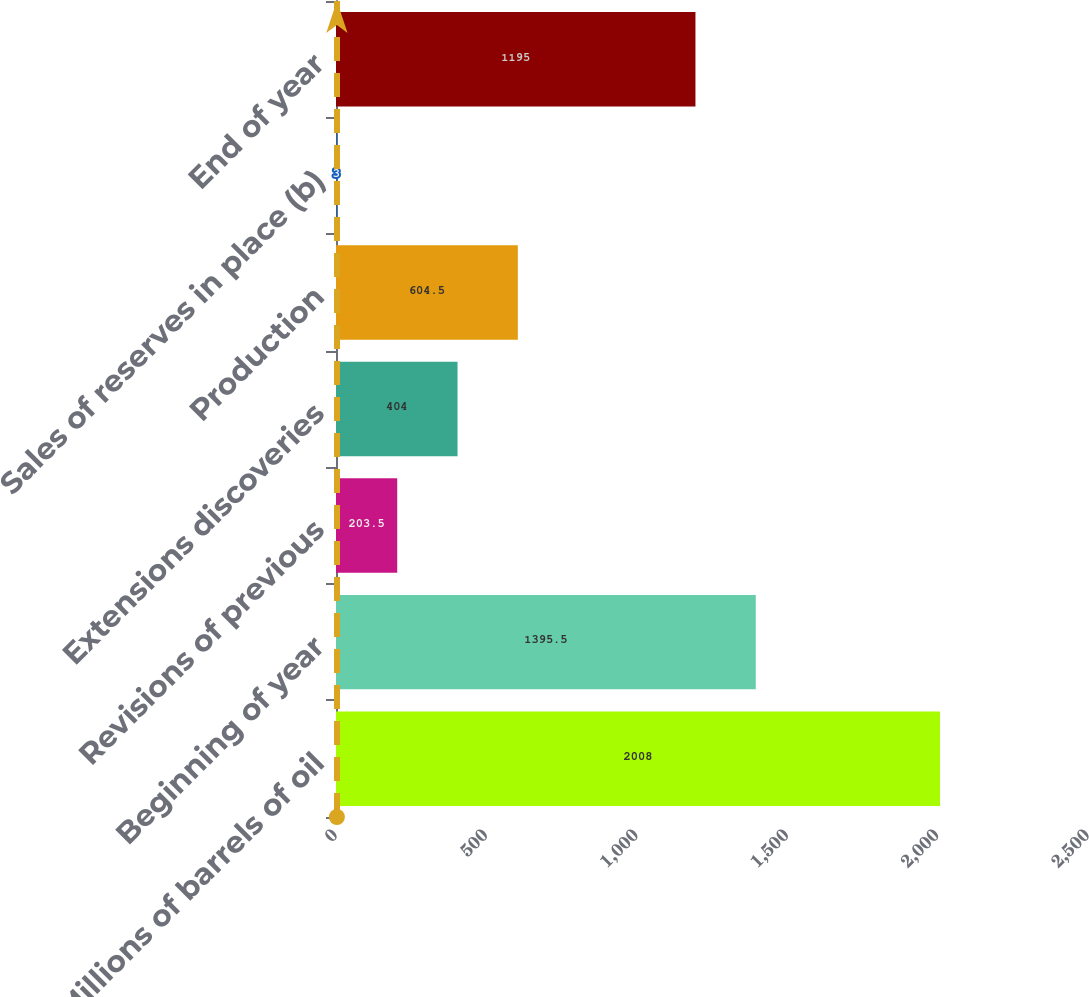<chart> <loc_0><loc_0><loc_500><loc_500><bar_chart><fcel>(Millions of barrels of oil<fcel>Beginning of year<fcel>Revisions of previous<fcel>Extensions discoveries<fcel>Production<fcel>Sales of reserves in place (b)<fcel>End of year<nl><fcel>2008<fcel>1395.5<fcel>203.5<fcel>404<fcel>604.5<fcel>3<fcel>1195<nl></chart> 